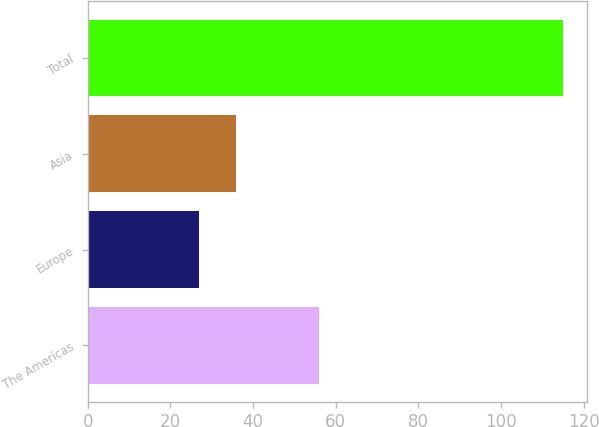<chart> <loc_0><loc_0><loc_500><loc_500><bar_chart><fcel>The Americas<fcel>Europe<fcel>Asia<fcel>Total<nl><fcel>56<fcel>27<fcel>35.8<fcel>115<nl></chart> 